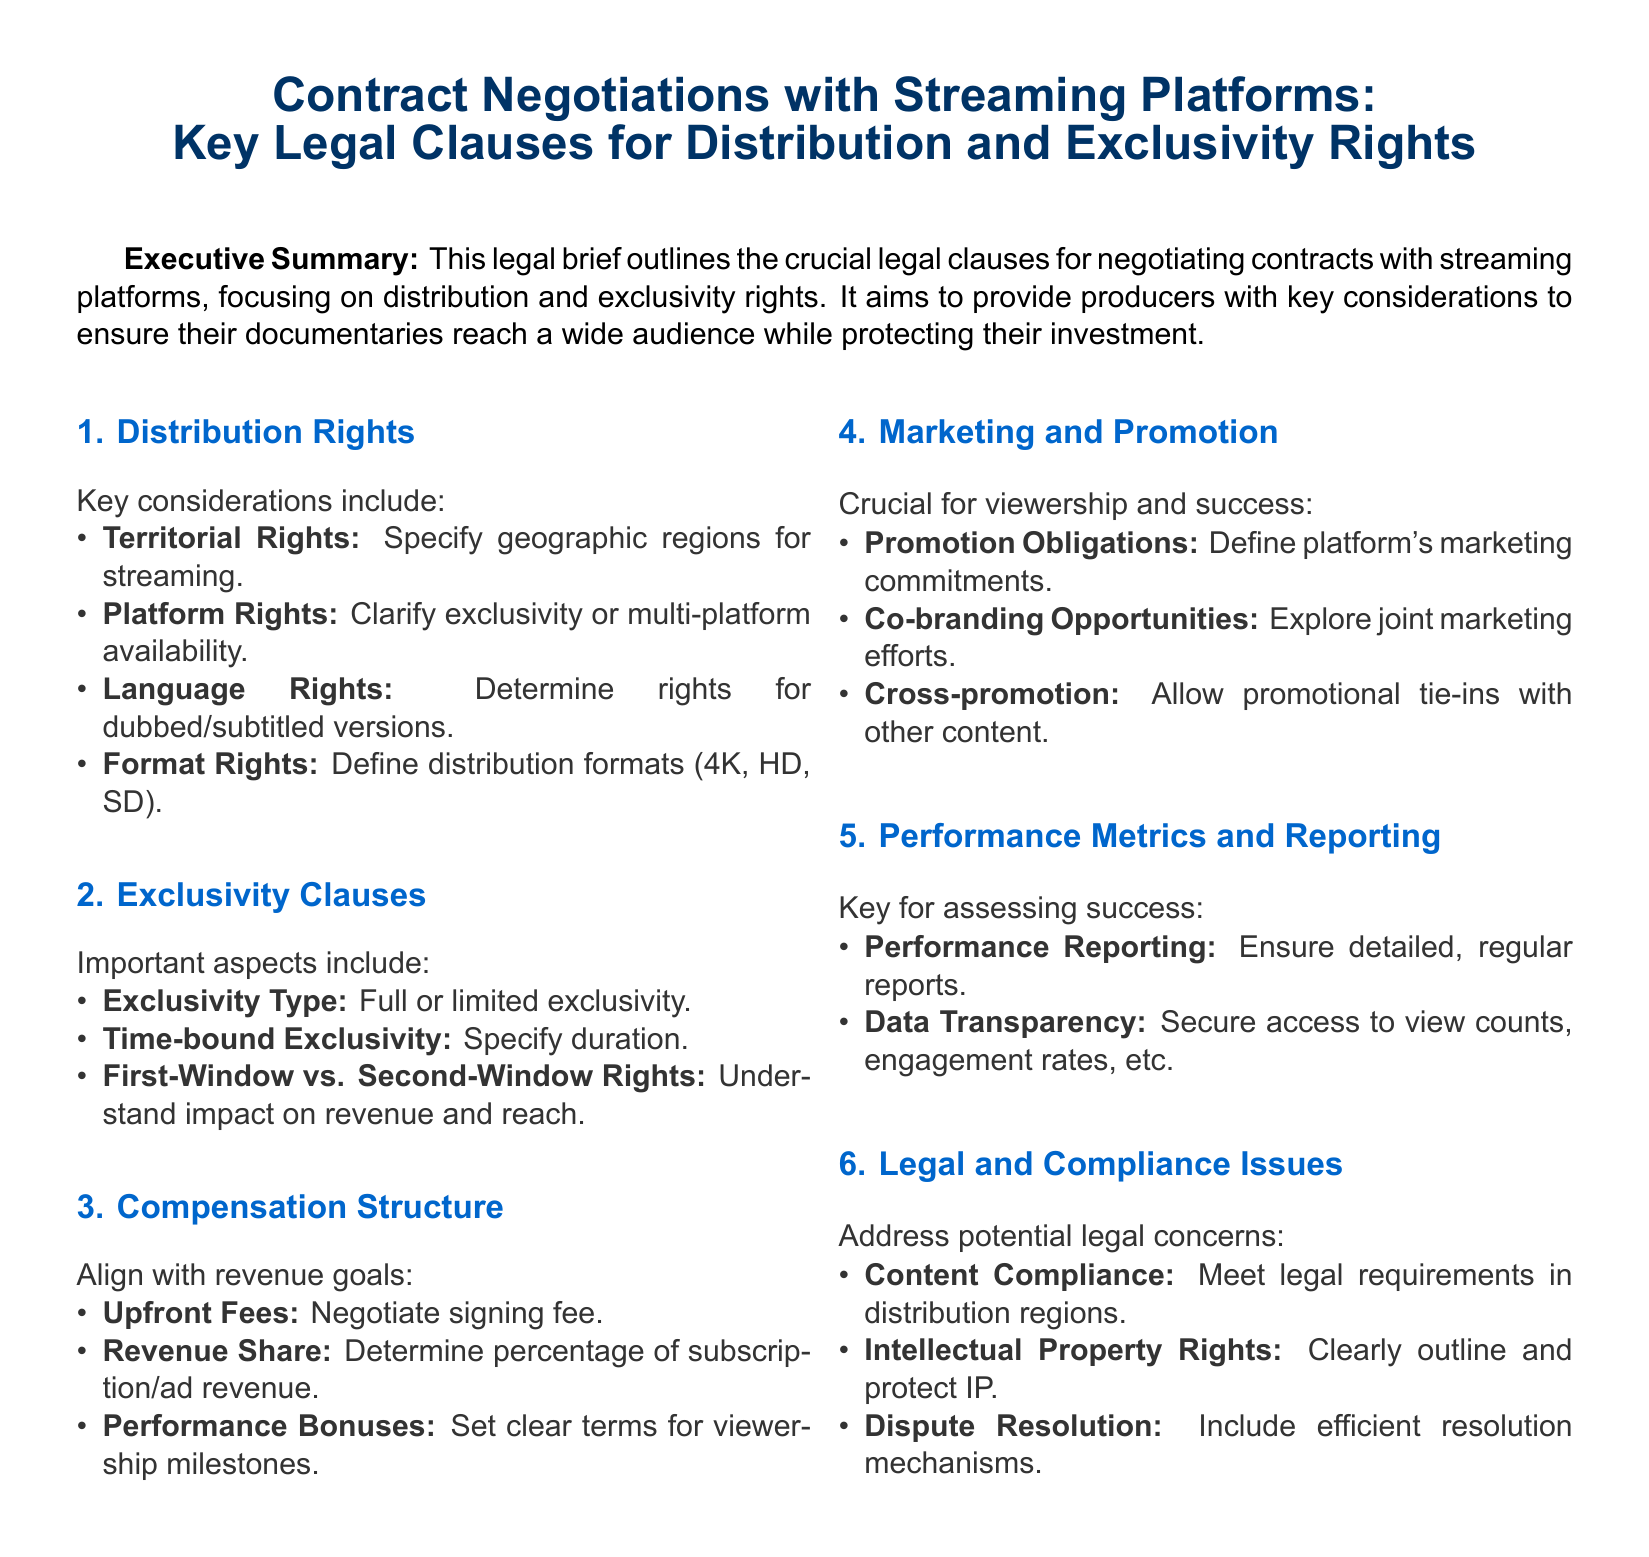What are the key considerations for distribution rights? The key considerations listed under distribution rights include territorial rights, platform rights, language rights, and format rights.
Answer: Territorial rights, platform rights, language rights, format rights What are the five clauses that are important for exclusivity? The document defines important aspects of exclusivity clauses as exclusivity type, time-bound exclusivity, and first-window vs. second-window rights.
Answer: Exclusivity type, time-bound exclusivity, first-window vs. second-window rights What term refers to additional payment triggered by viewership? The term that refers to additional payment based on viewership milestones is performance bonuses.
Answer: Performance bonuses What is required for assessing documentary success? The required aspect for assessing success is performance metrics and detailed reporting that ensures data transparency.
Answer: Performance metrics and data transparency How many sections are there in the document? The document contains six sections. Each section addresses different aspects of contract negotiations with streaming platforms.
Answer: Six What type of exclusivity can be specified in negotiations? The document mentions that exclusivity can be specified as full or limited.
Answer: Full or limited What does "co-branding opportunities" refer to in the marketing section? Co-branding opportunities refer to the exploration of joint marketing efforts between parties in the contract.
Answer: Joint marketing efforts What must be included in dispute resolution? The document indicates that efficient resolution mechanisms need to be included in dispute resolution clauses.
Answer: Efficient resolution mechanisms 